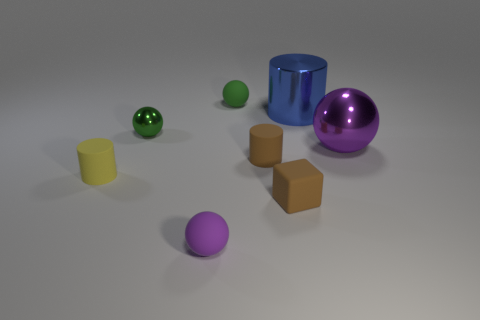Subtract all brown rubber cylinders. How many cylinders are left? 2 Add 1 tiny things. How many objects exist? 9 Subtract all red cylinders. How many purple spheres are left? 2 Subtract all blue cylinders. How many cylinders are left? 2 Subtract all cylinders. How many objects are left? 5 Subtract 0 yellow cubes. How many objects are left? 8 Subtract all gray cylinders. Subtract all red blocks. How many cylinders are left? 3 Subtract all red matte cylinders. Subtract all matte objects. How many objects are left? 3 Add 5 blue objects. How many blue objects are left? 6 Add 4 brown rubber objects. How many brown rubber objects exist? 6 